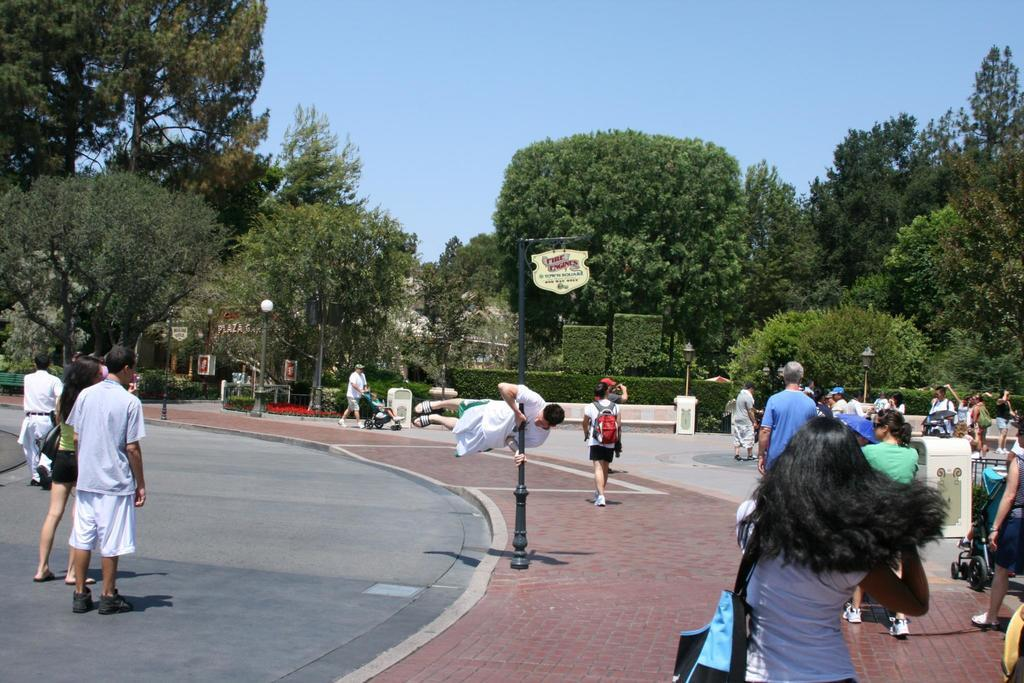What are the people in the image doing? The people in the image are walking on the road on the left side and on the footpath. What type of vegetation can be seen in the image? There are green color trees in the image. What is visible at the top of the image? The sky is visible at the top of the image. What type of crack is visible on the road in the image? There is no crack visible on the road in the image. What type of iron object can be seen in the image? There is no iron object present in the image. 